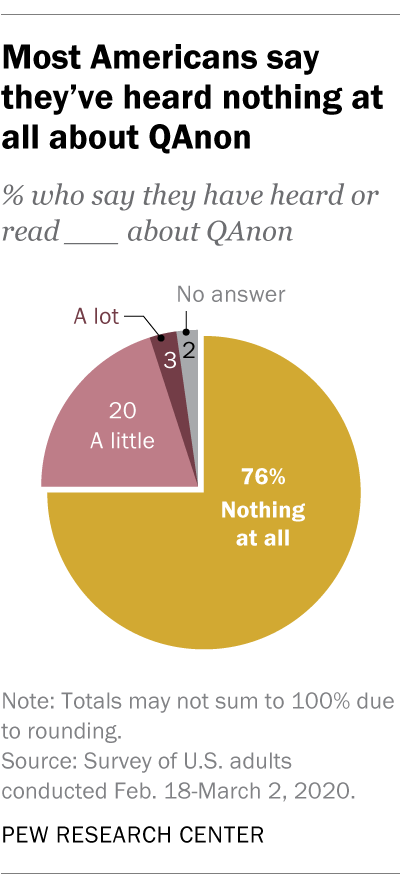List a handful of essential elements in this visual. The yellow part in the chart indicates nothing at all. The difference in value between 'A little' and 'A lot' is 0.17... 